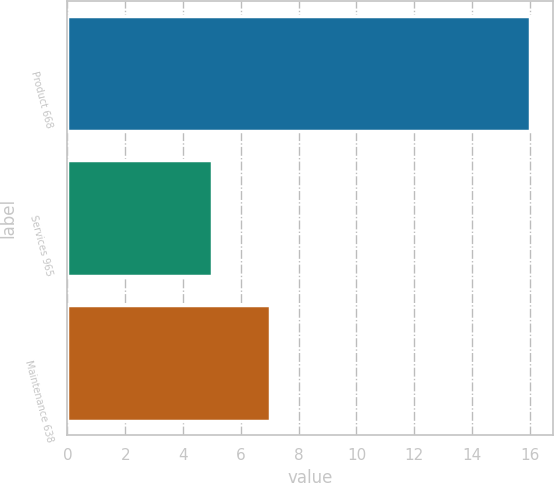<chart> <loc_0><loc_0><loc_500><loc_500><bar_chart><fcel>Product 668<fcel>Services 965<fcel>Maintenance 638<nl><fcel>16<fcel>5<fcel>7<nl></chart> 